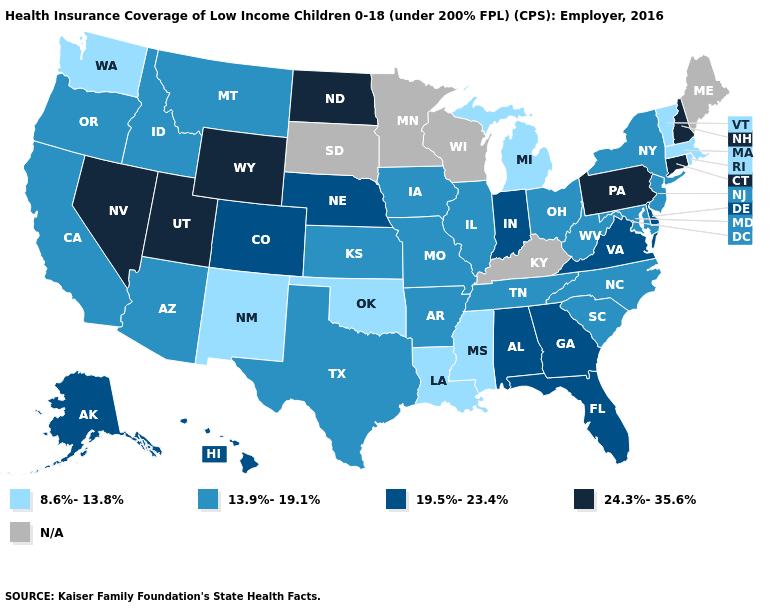What is the value of South Carolina?
Answer briefly. 13.9%-19.1%. Which states have the lowest value in the USA?
Answer briefly. Louisiana, Massachusetts, Michigan, Mississippi, New Mexico, Oklahoma, Rhode Island, Vermont, Washington. Does Virginia have the lowest value in the USA?
Give a very brief answer. No. Does Michigan have the lowest value in the USA?
Keep it brief. Yes. How many symbols are there in the legend?
Give a very brief answer. 5. How many symbols are there in the legend?
Be succinct. 5. What is the lowest value in states that border Maryland?
Keep it brief. 13.9%-19.1%. What is the value of Colorado?
Be succinct. 19.5%-23.4%. What is the highest value in states that border Maine?
Concise answer only. 24.3%-35.6%. How many symbols are there in the legend?
Give a very brief answer. 5. 